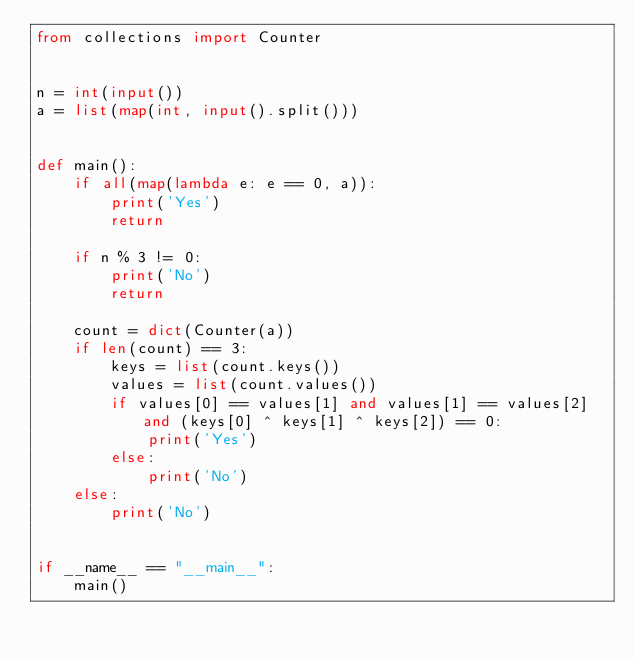<code> <loc_0><loc_0><loc_500><loc_500><_Python_>from collections import Counter


n = int(input())
a = list(map(int, input().split()))


def main():
    if all(map(lambda e: e == 0, a)):
        print('Yes')
        return

    if n % 3 != 0:
        print('No')
        return

    count = dict(Counter(a))
    if len(count) == 3:
        keys = list(count.keys())
        values = list(count.values())
        if values[0] == values[1] and values[1] == values[2] and (keys[0] ^ keys[1] ^ keys[2]) == 0:
            print('Yes')
        else:
            print('No')
    else:
        print('No')


if __name__ == "__main__":
    main()
    </code> 